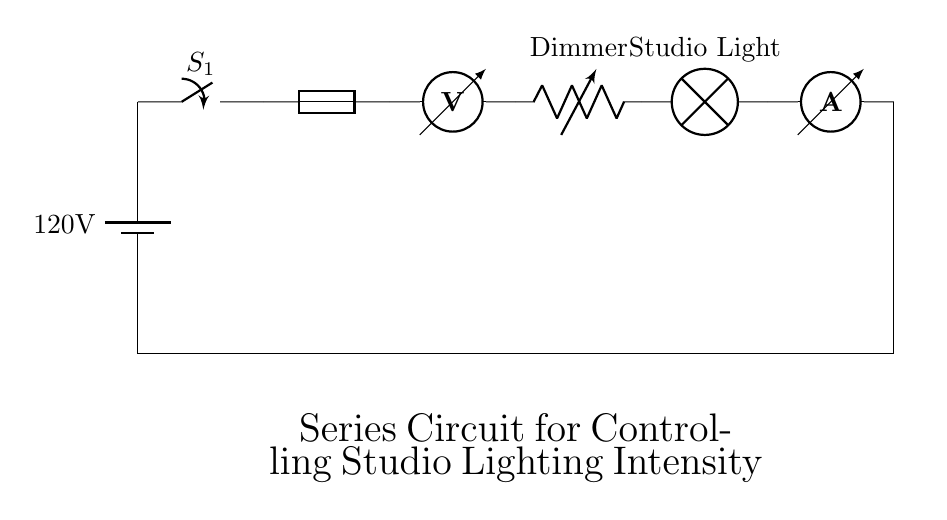What is the voltage of the power source? The voltage of the power source is indicated on the battery symbol. It states "120V" as the supplied voltage to the circuit.
Answer: 120V What component is used to control the intensity of the studio light? The circuit includes a variable resistor labeled as a dimmer, denoted as "R1." This component allows for the adjustment of the light intensity by varying resistance.
Answer: Dimmer How many main components are in this series circuit? The circuit diagram consists of six main components: a battery, a switch, a fuse, a voltmeter, a variable resistor (dimmer), and an ammeter, totaling six components.
Answer: Six What type of circuit is this? This is a series circuit, as all components are connected end-to-end in a single pathway for current flow. If one component fails, the entire circuit will stop functioning.
Answer: Series What role does the fuse play in this circuit? The fuse protects the circuit from overcurrent by breaking the circuit when the current exceeds a certain level, preventing damage to other components.
Answer: Protection What happens to the current if the dimmer is turned down? If the dimmer is turned down, the resistance increases, leading to a decrease in current flow through the circuit, based on Ohm's Law, where increasing resistance decreases current at a constant voltage.
Answer: Decrease 